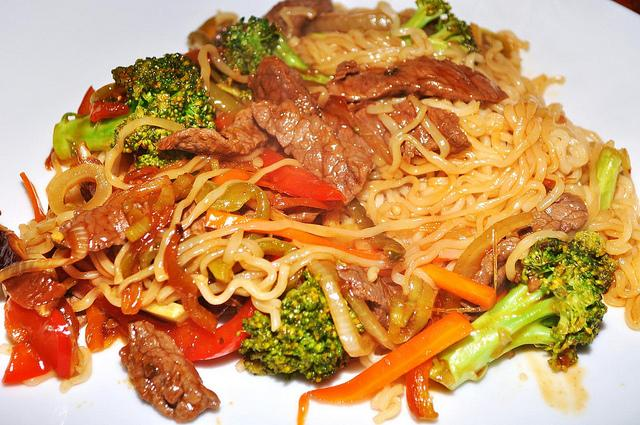What is touching the broccoli? noodles 